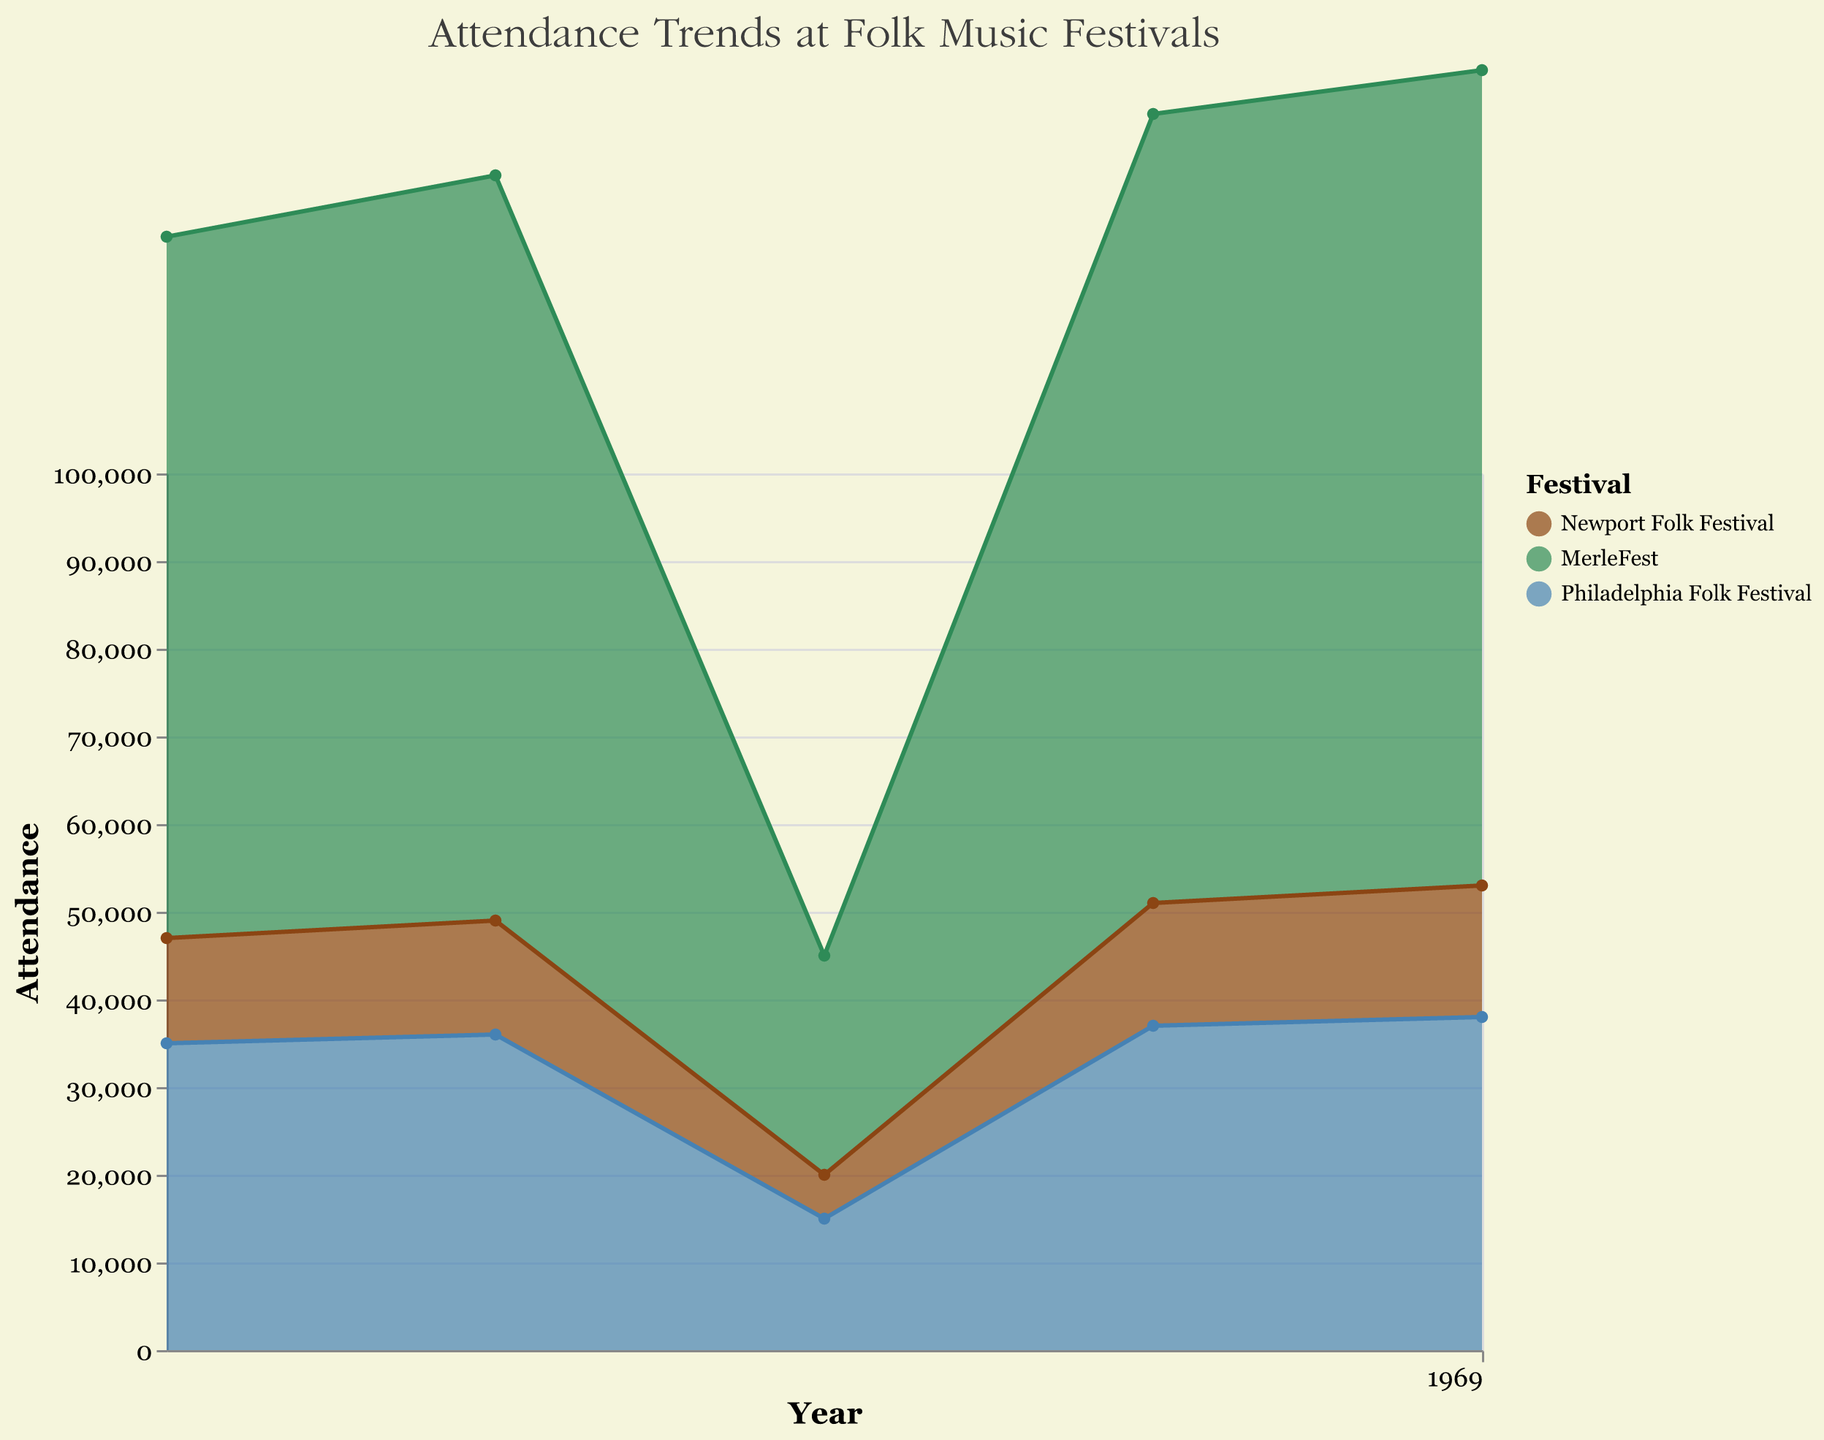What is the title of the chart? The title is located at the top of the chart and reads "Attendance Trends at Folk Music Festivals".
Answer: Attendance Trends at Folk Music Festivals How does the attendance at the Newport Folk Festival change from 2018 to 2022? In 2018, the attendance was 12,000. It increased to 13,000 in 2019, dropped to 5,000 in 2020, then gradually increased to 14,000 in 2021 and 15,000 in 2022.
Answer: It fluctuates, with a substantial drop in 2020, but overall it increases Which festival had the highest attendance in 2022? By looking at the attendance values for 2022, MerleFest had 93,000 attendees, which is higher than the other festivals.
Answer: MerleFest Compare the attendance at MerleFest in 2018 and 2022. What is the difference? The attendance at MerleFest was 80,000 in 2018 and 93,000 in 2022. Subtracting these values gives the difference: 93,000 - 80,000 = 13,000.
Answer: 13,000 Which festival experienced the largest drop in attendance between any two consecutive years? The Newport Folk Festival had the largest drop in attendance between 2019 (13,000) and 2020 (5,000), resulting in a reduction of 8,000 attendees.
Answer: Newport Folk Festival, 8,000 How did the overall attendance at all festivals change from 2019 to 2020? Sum the attendance of all festivals in 2019 (13,000 + 85,000 + 36,000 = 134,000) and 2020 (5,000 + 25,000 + 15,000 = 45,000). The change is 134,000 - 45,000, which is a reduction of 89,000.
Answer: Decreased by 89,000 Compare the attendance trend of the Philadelphia Folk Festival to Newport Folk Festival from 2018 to 2022. The Philadelphia Folk Festival shows a consistent increase over the years except for a drop in 2020, from 35,000 to 38,000. Newport Folk Festival attendance fluctuates more, with a significant drop in 2020 and then recovery.
Answer: Philadelphia Folk Festival shows a steadier increase What was the attendance at the Philadelphia Folk Festival in 2021 and how does it compare to the previous year? In 2021, the attendance was 37,000. The previous year, 2020, had 15,000 attendees, so there was an increase of 37,000 - 15,000 = 22,000.
Answer: Increased by 22,000 Which festival recovered the fastest from the drop in 2020? Comparing changes from 2020 to 2021, Newport Folk Festival rose from 5,000 to 14,000 (increase of 9,000), MerleFest from 25,000 to 90,000 (increase of 65,000), and Philadelphia Folk Festival from 15,000 to 37,000 (increase of 22,000). MerleFest had the largest increase.
Answer: MerleFest How does the variance in attendance for each festival compare? Calculate the range (max - min) for each festival from 2018 to 2022. Newport: 15,000 - 5,000 (10,000), MerleFest: 93,000 - 25,000 (68,000), Philadelphia: 38,000 - 15,000 (23,000). MerleFest has the highest variance.
Answer: MerleFest has the highest variance 